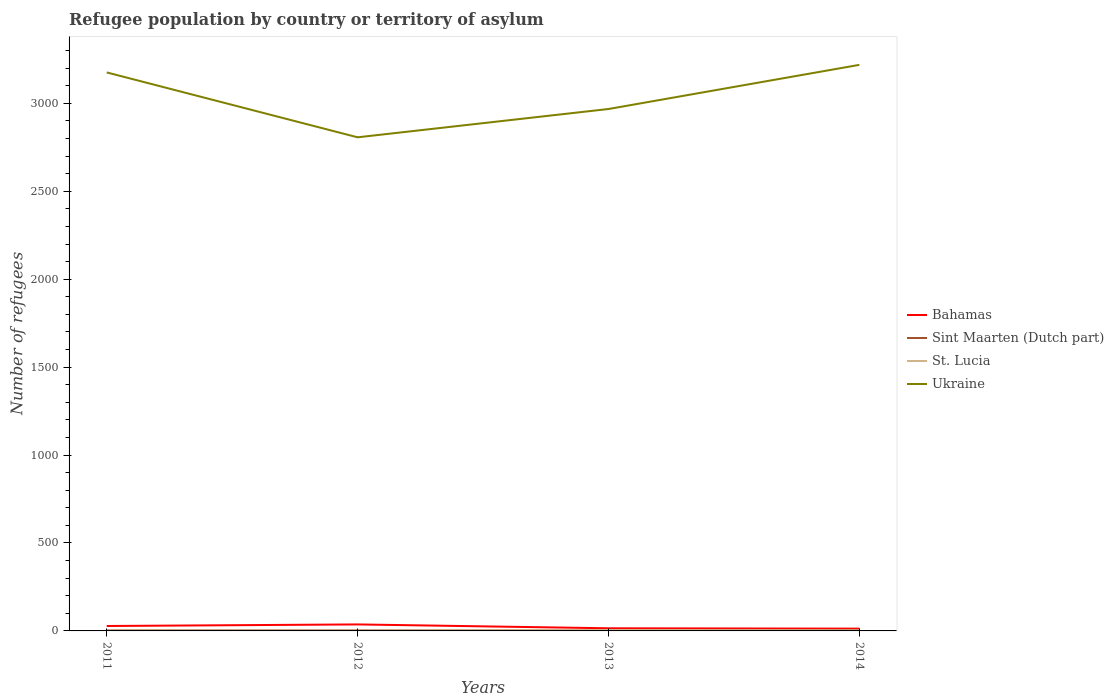How many different coloured lines are there?
Ensure brevity in your answer.  4. Does the line corresponding to Ukraine intersect with the line corresponding to Sint Maarten (Dutch part)?
Your answer should be compact. No. Across all years, what is the maximum number of refugees in Ukraine?
Provide a succinct answer. 2807. In which year was the number of refugees in St. Lucia maximum?
Make the answer very short. 2011. What is the difference between the highest and the second highest number of refugees in Ukraine?
Provide a succinct answer. 412. Is the number of refugees in Bahamas strictly greater than the number of refugees in St. Lucia over the years?
Keep it short and to the point. No. What is the difference between two consecutive major ticks on the Y-axis?
Offer a very short reply. 500. Does the graph contain any zero values?
Your response must be concise. No. Does the graph contain grids?
Give a very brief answer. No. How many legend labels are there?
Offer a very short reply. 4. What is the title of the graph?
Provide a short and direct response. Refugee population by country or territory of asylum. Does "Guam" appear as one of the legend labels in the graph?
Provide a short and direct response. No. What is the label or title of the X-axis?
Offer a terse response. Years. What is the label or title of the Y-axis?
Your response must be concise. Number of refugees. What is the Number of refugees of Bahamas in 2011?
Your answer should be very brief. 28. What is the Number of refugees in Sint Maarten (Dutch part) in 2011?
Give a very brief answer. 3. What is the Number of refugees in St. Lucia in 2011?
Offer a terse response. 2. What is the Number of refugees in Ukraine in 2011?
Your response must be concise. 3176. What is the Number of refugees in Sint Maarten (Dutch part) in 2012?
Make the answer very short. 3. What is the Number of refugees of St. Lucia in 2012?
Your response must be concise. 2. What is the Number of refugees in Ukraine in 2012?
Your answer should be compact. 2807. What is the Number of refugees of Bahamas in 2013?
Keep it short and to the point. 15. What is the Number of refugees of Sint Maarten (Dutch part) in 2013?
Your answer should be compact. 3. What is the Number of refugees of Ukraine in 2013?
Offer a terse response. 2968. What is the Number of refugees of Ukraine in 2014?
Make the answer very short. 3219. Across all years, what is the maximum Number of refugees of Sint Maarten (Dutch part)?
Offer a terse response. 3. Across all years, what is the maximum Number of refugees in Ukraine?
Keep it short and to the point. 3219. Across all years, what is the minimum Number of refugees of St. Lucia?
Ensure brevity in your answer.  2. Across all years, what is the minimum Number of refugees of Ukraine?
Ensure brevity in your answer.  2807. What is the total Number of refugees of Bahamas in the graph?
Your answer should be compact. 93. What is the total Number of refugees of Sint Maarten (Dutch part) in the graph?
Make the answer very short. 12. What is the total Number of refugees of St. Lucia in the graph?
Ensure brevity in your answer.  12. What is the total Number of refugees in Ukraine in the graph?
Offer a terse response. 1.22e+04. What is the difference between the Number of refugees in Bahamas in 2011 and that in 2012?
Make the answer very short. -9. What is the difference between the Number of refugees of St. Lucia in 2011 and that in 2012?
Keep it short and to the point. 0. What is the difference between the Number of refugees of Ukraine in 2011 and that in 2012?
Provide a succinct answer. 369. What is the difference between the Number of refugees in Sint Maarten (Dutch part) in 2011 and that in 2013?
Provide a short and direct response. 0. What is the difference between the Number of refugees in Ukraine in 2011 and that in 2013?
Keep it short and to the point. 208. What is the difference between the Number of refugees of Sint Maarten (Dutch part) in 2011 and that in 2014?
Provide a short and direct response. 0. What is the difference between the Number of refugees of St. Lucia in 2011 and that in 2014?
Your answer should be very brief. -1. What is the difference between the Number of refugees in Ukraine in 2011 and that in 2014?
Offer a terse response. -43. What is the difference between the Number of refugees of Sint Maarten (Dutch part) in 2012 and that in 2013?
Your response must be concise. 0. What is the difference between the Number of refugees of Ukraine in 2012 and that in 2013?
Make the answer very short. -161. What is the difference between the Number of refugees in Sint Maarten (Dutch part) in 2012 and that in 2014?
Your answer should be very brief. 0. What is the difference between the Number of refugees of St. Lucia in 2012 and that in 2014?
Your answer should be compact. -1. What is the difference between the Number of refugees of Ukraine in 2012 and that in 2014?
Your response must be concise. -412. What is the difference between the Number of refugees in Bahamas in 2013 and that in 2014?
Offer a terse response. 2. What is the difference between the Number of refugees in Ukraine in 2013 and that in 2014?
Your answer should be very brief. -251. What is the difference between the Number of refugees of Bahamas in 2011 and the Number of refugees of Sint Maarten (Dutch part) in 2012?
Your answer should be very brief. 25. What is the difference between the Number of refugees of Bahamas in 2011 and the Number of refugees of St. Lucia in 2012?
Give a very brief answer. 26. What is the difference between the Number of refugees in Bahamas in 2011 and the Number of refugees in Ukraine in 2012?
Your answer should be very brief. -2779. What is the difference between the Number of refugees of Sint Maarten (Dutch part) in 2011 and the Number of refugees of St. Lucia in 2012?
Offer a very short reply. 1. What is the difference between the Number of refugees of Sint Maarten (Dutch part) in 2011 and the Number of refugees of Ukraine in 2012?
Make the answer very short. -2804. What is the difference between the Number of refugees of St. Lucia in 2011 and the Number of refugees of Ukraine in 2012?
Make the answer very short. -2805. What is the difference between the Number of refugees in Bahamas in 2011 and the Number of refugees in Ukraine in 2013?
Your response must be concise. -2940. What is the difference between the Number of refugees of Sint Maarten (Dutch part) in 2011 and the Number of refugees of St. Lucia in 2013?
Offer a very short reply. -2. What is the difference between the Number of refugees of Sint Maarten (Dutch part) in 2011 and the Number of refugees of Ukraine in 2013?
Your answer should be compact. -2965. What is the difference between the Number of refugees of St. Lucia in 2011 and the Number of refugees of Ukraine in 2013?
Provide a succinct answer. -2966. What is the difference between the Number of refugees in Bahamas in 2011 and the Number of refugees in Sint Maarten (Dutch part) in 2014?
Ensure brevity in your answer.  25. What is the difference between the Number of refugees in Bahamas in 2011 and the Number of refugees in Ukraine in 2014?
Offer a terse response. -3191. What is the difference between the Number of refugees in Sint Maarten (Dutch part) in 2011 and the Number of refugees in Ukraine in 2014?
Provide a short and direct response. -3216. What is the difference between the Number of refugees in St. Lucia in 2011 and the Number of refugees in Ukraine in 2014?
Offer a terse response. -3217. What is the difference between the Number of refugees in Bahamas in 2012 and the Number of refugees in Ukraine in 2013?
Your answer should be compact. -2931. What is the difference between the Number of refugees of Sint Maarten (Dutch part) in 2012 and the Number of refugees of Ukraine in 2013?
Provide a short and direct response. -2965. What is the difference between the Number of refugees of St. Lucia in 2012 and the Number of refugees of Ukraine in 2013?
Offer a very short reply. -2966. What is the difference between the Number of refugees in Bahamas in 2012 and the Number of refugees in Sint Maarten (Dutch part) in 2014?
Provide a succinct answer. 34. What is the difference between the Number of refugees of Bahamas in 2012 and the Number of refugees of Ukraine in 2014?
Offer a very short reply. -3182. What is the difference between the Number of refugees in Sint Maarten (Dutch part) in 2012 and the Number of refugees in St. Lucia in 2014?
Ensure brevity in your answer.  0. What is the difference between the Number of refugees of Sint Maarten (Dutch part) in 2012 and the Number of refugees of Ukraine in 2014?
Your response must be concise. -3216. What is the difference between the Number of refugees of St. Lucia in 2012 and the Number of refugees of Ukraine in 2014?
Ensure brevity in your answer.  -3217. What is the difference between the Number of refugees in Bahamas in 2013 and the Number of refugees in St. Lucia in 2014?
Ensure brevity in your answer.  12. What is the difference between the Number of refugees of Bahamas in 2013 and the Number of refugees of Ukraine in 2014?
Offer a very short reply. -3204. What is the difference between the Number of refugees in Sint Maarten (Dutch part) in 2013 and the Number of refugees in St. Lucia in 2014?
Provide a succinct answer. 0. What is the difference between the Number of refugees of Sint Maarten (Dutch part) in 2013 and the Number of refugees of Ukraine in 2014?
Keep it short and to the point. -3216. What is the difference between the Number of refugees in St. Lucia in 2013 and the Number of refugees in Ukraine in 2014?
Offer a terse response. -3214. What is the average Number of refugees in Bahamas per year?
Keep it short and to the point. 23.25. What is the average Number of refugees of Sint Maarten (Dutch part) per year?
Give a very brief answer. 3. What is the average Number of refugees in Ukraine per year?
Ensure brevity in your answer.  3042.5. In the year 2011, what is the difference between the Number of refugees in Bahamas and Number of refugees in Sint Maarten (Dutch part)?
Provide a short and direct response. 25. In the year 2011, what is the difference between the Number of refugees in Bahamas and Number of refugees in Ukraine?
Your response must be concise. -3148. In the year 2011, what is the difference between the Number of refugees of Sint Maarten (Dutch part) and Number of refugees of Ukraine?
Ensure brevity in your answer.  -3173. In the year 2011, what is the difference between the Number of refugees in St. Lucia and Number of refugees in Ukraine?
Your response must be concise. -3174. In the year 2012, what is the difference between the Number of refugees of Bahamas and Number of refugees of Ukraine?
Provide a short and direct response. -2770. In the year 2012, what is the difference between the Number of refugees in Sint Maarten (Dutch part) and Number of refugees in Ukraine?
Make the answer very short. -2804. In the year 2012, what is the difference between the Number of refugees of St. Lucia and Number of refugees of Ukraine?
Provide a succinct answer. -2805. In the year 2013, what is the difference between the Number of refugees of Bahamas and Number of refugees of Sint Maarten (Dutch part)?
Provide a succinct answer. 12. In the year 2013, what is the difference between the Number of refugees in Bahamas and Number of refugees in St. Lucia?
Ensure brevity in your answer.  10. In the year 2013, what is the difference between the Number of refugees in Bahamas and Number of refugees in Ukraine?
Provide a short and direct response. -2953. In the year 2013, what is the difference between the Number of refugees in Sint Maarten (Dutch part) and Number of refugees in St. Lucia?
Offer a very short reply. -2. In the year 2013, what is the difference between the Number of refugees in Sint Maarten (Dutch part) and Number of refugees in Ukraine?
Your answer should be compact. -2965. In the year 2013, what is the difference between the Number of refugees of St. Lucia and Number of refugees of Ukraine?
Ensure brevity in your answer.  -2963. In the year 2014, what is the difference between the Number of refugees in Bahamas and Number of refugees in Ukraine?
Make the answer very short. -3206. In the year 2014, what is the difference between the Number of refugees of Sint Maarten (Dutch part) and Number of refugees of Ukraine?
Keep it short and to the point. -3216. In the year 2014, what is the difference between the Number of refugees of St. Lucia and Number of refugees of Ukraine?
Your answer should be very brief. -3216. What is the ratio of the Number of refugees in Bahamas in 2011 to that in 2012?
Your answer should be compact. 0.76. What is the ratio of the Number of refugees in Sint Maarten (Dutch part) in 2011 to that in 2012?
Offer a terse response. 1. What is the ratio of the Number of refugees of Ukraine in 2011 to that in 2012?
Keep it short and to the point. 1.13. What is the ratio of the Number of refugees of Bahamas in 2011 to that in 2013?
Make the answer very short. 1.87. What is the ratio of the Number of refugees in Ukraine in 2011 to that in 2013?
Offer a very short reply. 1.07. What is the ratio of the Number of refugees in Bahamas in 2011 to that in 2014?
Keep it short and to the point. 2.15. What is the ratio of the Number of refugees of Sint Maarten (Dutch part) in 2011 to that in 2014?
Ensure brevity in your answer.  1. What is the ratio of the Number of refugees in St. Lucia in 2011 to that in 2014?
Your answer should be compact. 0.67. What is the ratio of the Number of refugees in Ukraine in 2011 to that in 2014?
Make the answer very short. 0.99. What is the ratio of the Number of refugees in Bahamas in 2012 to that in 2013?
Offer a terse response. 2.47. What is the ratio of the Number of refugees in Ukraine in 2012 to that in 2013?
Your answer should be very brief. 0.95. What is the ratio of the Number of refugees of Bahamas in 2012 to that in 2014?
Your response must be concise. 2.85. What is the ratio of the Number of refugees of St. Lucia in 2012 to that in 2014?
Provide a succinct answer. 0.67. What is the ratio of the Number of refugees in Ukraine in 2012 to that in 2014?
Make the answer very short. 0.87. What is the ratio of the Number of refugees of Bahamas in 2013 to that in 2014?
Offer a very short reply. 1.15. What is the ratio of the Number of refugees in Ukraine in 2013 to that in 2014?
Offer a terse response. 0.92. What is the difference between the highest and the second highest Number of refugees of Sint Maarten (Dutch part)?
Offer a terse response. 0. What is the difference between the highest and the lowest Number of refugees in Bahamas?
Offer a very short reply. 24. What is the difference between the highest and the lowest Number of refugees of Ukraine?
Make the answer very short. 412. 